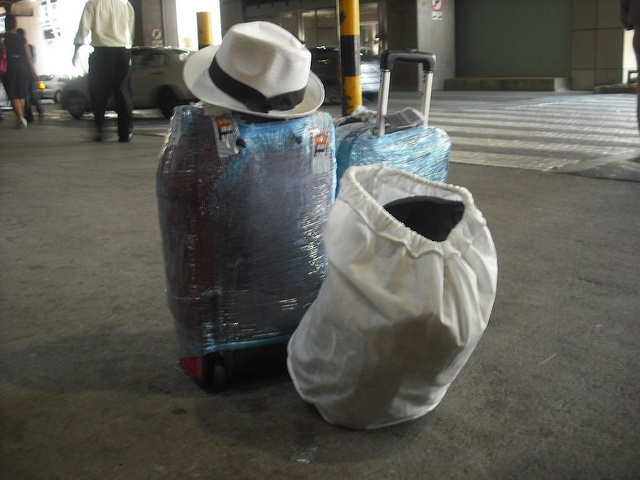Describe the objects in this image and their specific colors. I can see suitcase in black, gray, darkgray, and blue tones, people in black, darkgray, lightgray, and beige tones, suitcase in black, lightblue, and gray tones, car in black and gray tones, and people in black, gray, and maroon tones in this image. 